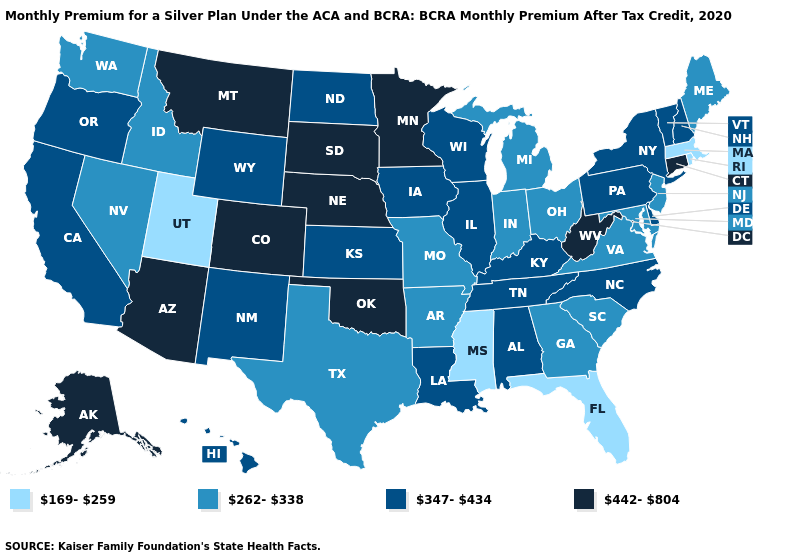Is the legend a continuous bar?
Keep it brief. No. Name the states that have a value in the range 442-804?
Concise answer only. Alaska, Arizona, Colorado, Connecticut, Minnesota, Montana, Nebraska, Oklahoma, South Dakota, West Virginia. How many symbols are there in the legend?
Short answer required. 4. Does Florida have the highest value in the USA?
Answer briefly. No. Name the states that have a value in the range 347-434?
Write a very short answer. Alabama, California, Delaware, Hawaii, Illinois, Iowa, Kansas, Kentucky, Louisiana, New Hampshire, New Mexico, New York, North Carolina, North Dakota, Oregon, Pennsylvania, Tennessee, Vermont, Wisconsin, Wyoming. Name the states that have a value in the range 169-259?
Keep it brief. Florida, Massachusetts, Mississippi, Rhode Island, Utah. Name the states that have a value in the range 442-804?
Quick response, please. Alaska, Arizona, Colorado, Connecticut, Minnesota, Montana, Nebraska, Oklahoma, South Dakota, West Virginia. Does Montana have the highest value in the West?
Be succinct. Yes. Name the states that have a value in the range 169-259?
Keep it brief. Florida, Massachusetts, Mississippi, Rhode Island, Utah. What is the highest value in the West ?
Quick response, please. 442-804. Which states hav the highest value in the West?
Write a very short answer. Alaska, Arizona, Colorado, Montana. What is the highest value in the Northeast ?
Write a very short answer. 442-804. Does Washington have the lowest value in the West?
Concise answer only. No. Which states have the highest value in the USA?
Give a very brief answer. Alaska, Arizona, Colorado, Connecticut, Minnesota, Montana, Nebraska, Oklahoma, South Dakota, West Virginia. Name the states that have a value in the range 347-434?
Be succinct. Alabama, California, Delaware, Hawaii, Illinois, Iowa, Kansas, Kentucky, Louisiana, New Hampshire, New Mexico, New York, North Carolina, North Dakota, Oregon, Pennsylvania, Tennessee, Vermont, Wisconsin, Wyoming. 